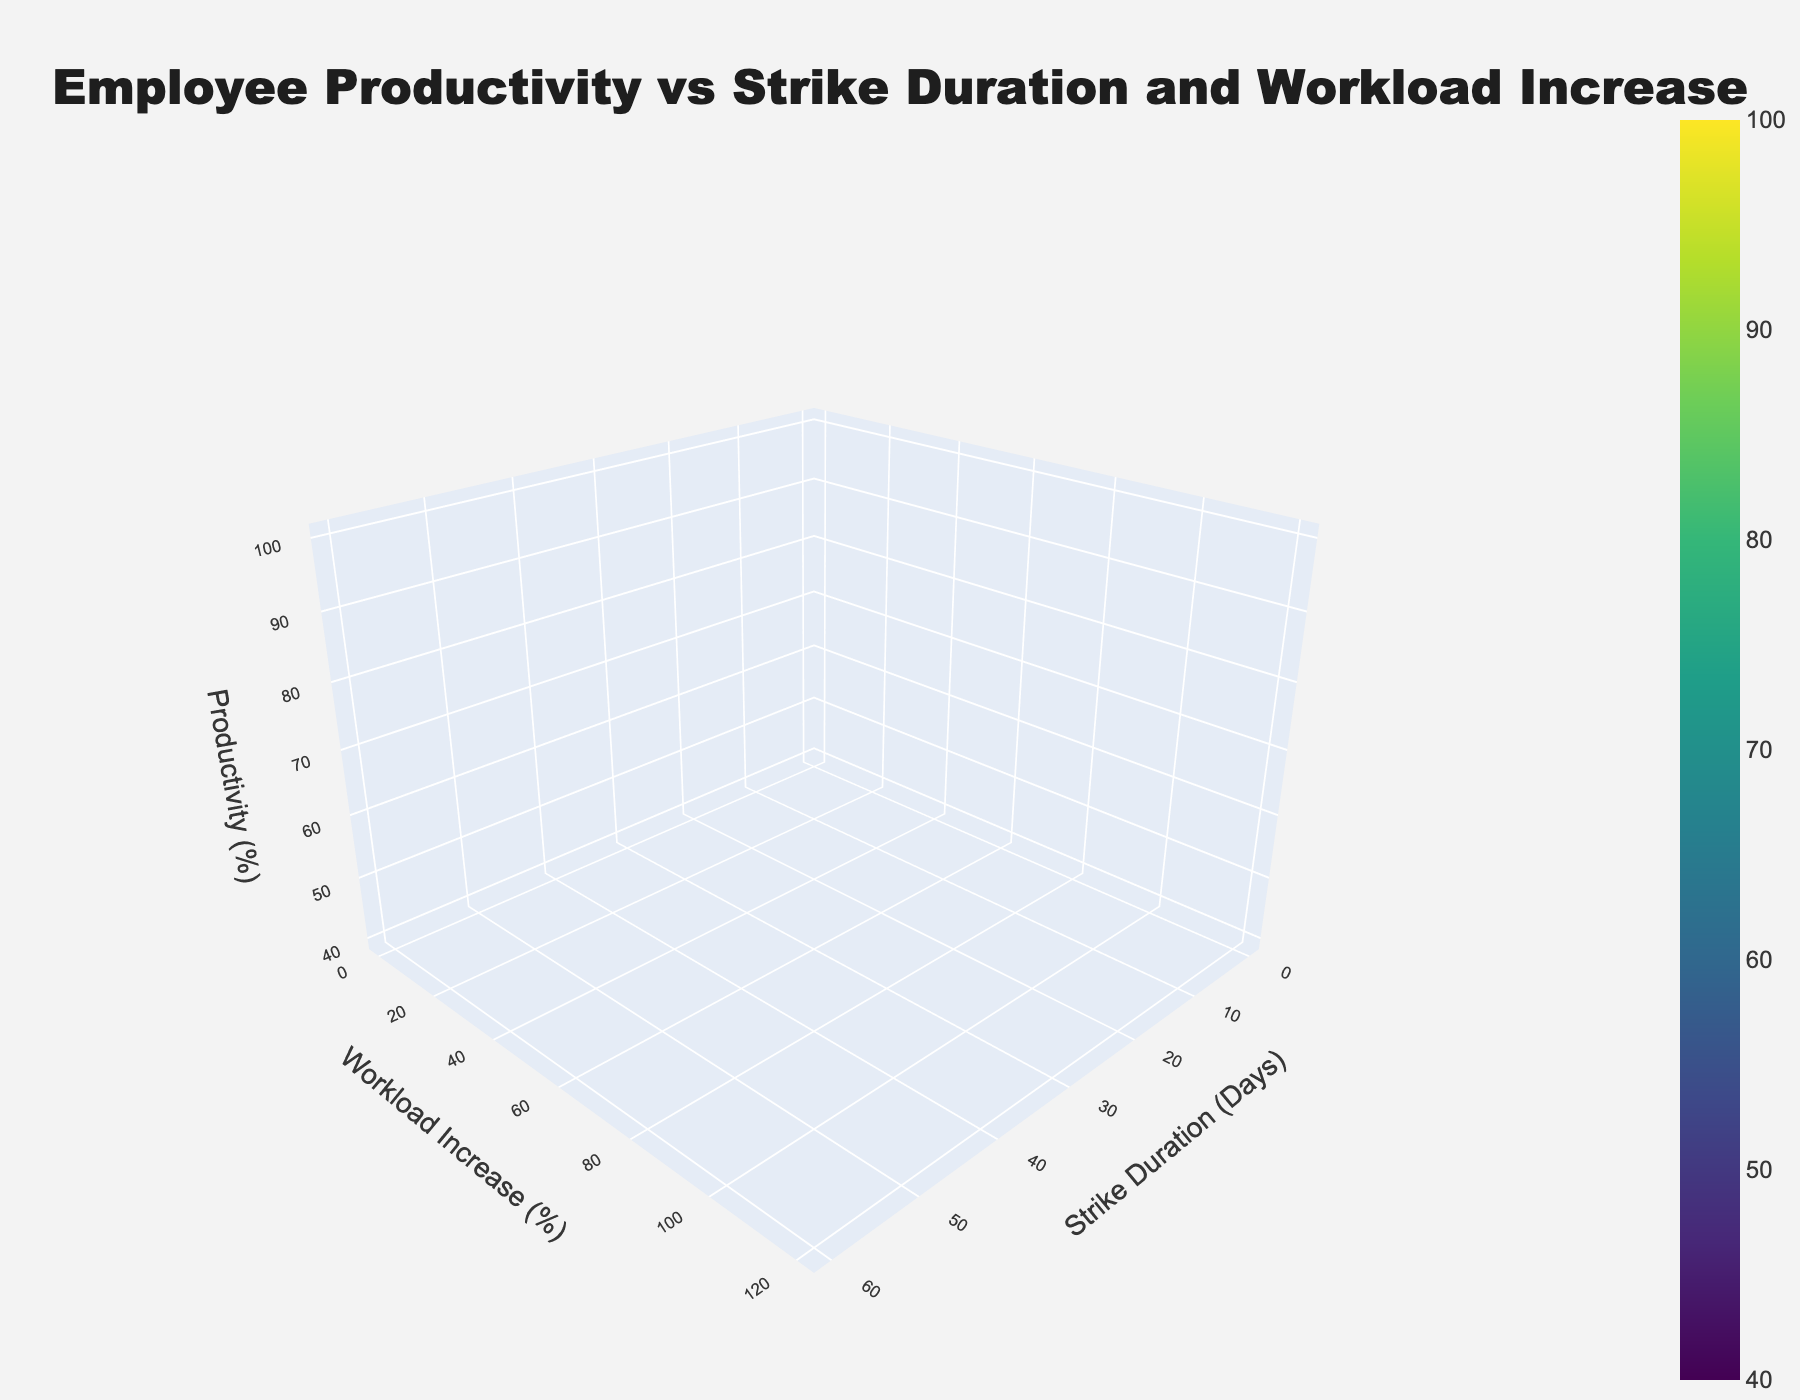What is the title of the 3D surface plot? The title is usually displayed at the top of the figure. In this case, it clearly states the focus of the plot.
Answer: Employee Productivity vs Strike Duration and Workload Increase What does the X-axis represent? The X-axis title is present in the figure and typically placed near the bottom of the axis.
Answer: Strike Duration (Days) What does the Z-axis represent? The Z-axis title is visible near the vertical axis of the figure.
Answer: Productivity (%) What pattern do you observe in productivity with increasing strike duration and workload? Observing the surface plot, productivity decreases as both strike duration and workload increase. The surface shows a downward trend from left to right and from low to high.
Answer: Productivity decreases At what point is employee productivity highest? Productivity is represented on the Z-axis, and the highest point on the surface plot corresponds to the lowest values of strike duration and workload increase on the X and Y axes, respectively.
Answer: Strike Duration: 0 days, Workload Increase: 0% How does productivity change when strike duration is 20 days and workload increase is 40%? Locate the point on the surface plot where Strike Duration is 20 days and Workload Increase is 40%. The corresponding Z-axis value shows the productivity.
Answer: 80% Which factor seems to have a greater impact on productivity, strike duration or workload increase? By visually inspecting the plot, the slope in the direction of workload increase (Y-axis) appears steeper than that of strike duration (X-axis), indicating a greater impact.
Answer: Workload increase How much does productivity decrease when the strike duration goes from 10 days to 30 days, assuming a proportional workload increase? Find productivity values at 10 days and 30 days on the surface plot, then calculate the difference.
Answer: 90% to 70%, decrease by 20% What is the productivity level when both strike duration and workload increase are at their midpoints? Midpoints can be approximated by values around 25 days for strike duration and 60% for workload increase. Use these points on the plot to find the corresponding productivity level.
Answer: Around 75% What is the general trend visible on the plot? By examining the color gradient and surface slope, one can see that productivity steadily decreases as both strike duration and workload increase.
Answer: Downward trend in productivity 